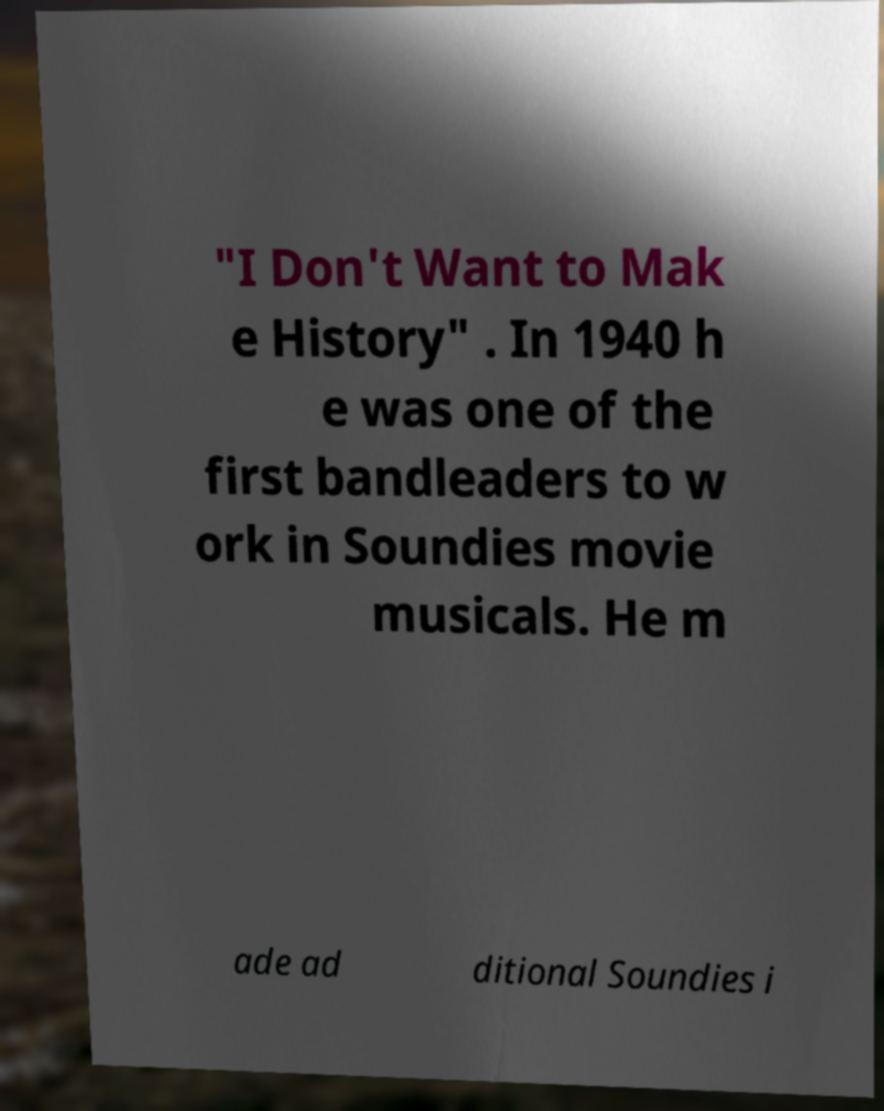Can you accurately transcribe the text from the provided image for me? "I Don't Want to Mak e History" . In 1940 h e was one of the first bandleaders to w ork in Soundies movie musicals. He m ade ad ditional Soundies i 